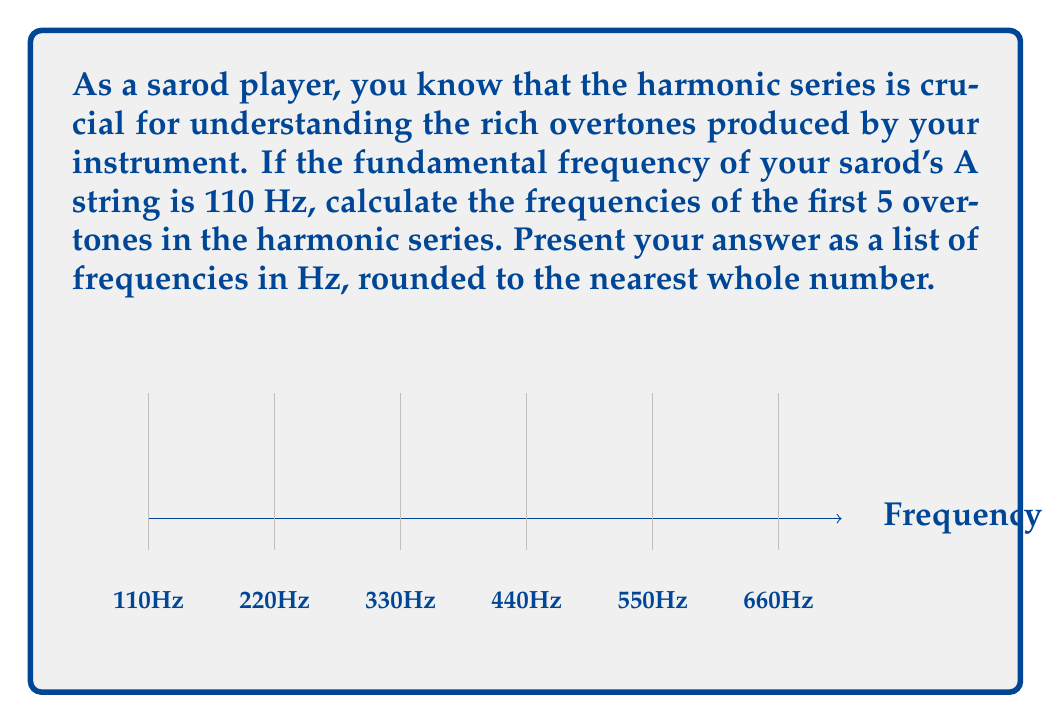Solve this math problem. To calculate the harmonic series of overtones:

1) The fundamental frequency $f_0$ is given as 110 Hz.

2) The formula for the nth harmonic in the series is:

   $$f_n = (n+1) \cdot f_0$$

   where $n$ is the overtone number (0 for fundamental, 1 for first overtone, etc.)

3) Let's calculate the first 5 overtones:

   First overtone ($n=1$):  $f_1 = (1+1) \cdot 110 = 2 \cdot 110 = 220$ Hz
   Second overtone ($n=2$): $f_2 = (2+1) \cdot 110 = 3 \cdot 110 = 330$ Hz
   Third overtone ($n=3$):  $f_3 = (3+1) \cdot 110 = 4 \cdot 110 = 440$ Hz
   Fourth overtone ($n=4$): $f_4 = (4+1) \cdot 110 = 5 \cdot 110 = 550$ Hz
   Fifth overtone ($n=5$):  $f_5 = (5+1) \cdot 110 = 6 \cdot 110 = 660$ Hz

4) Rounding to the nearest whole number is not necessary in this case as all results are already whole numbers.
Answer: 220 Hz, 330 Hz, 440 Hz, 550 Hz, 660 Hz 